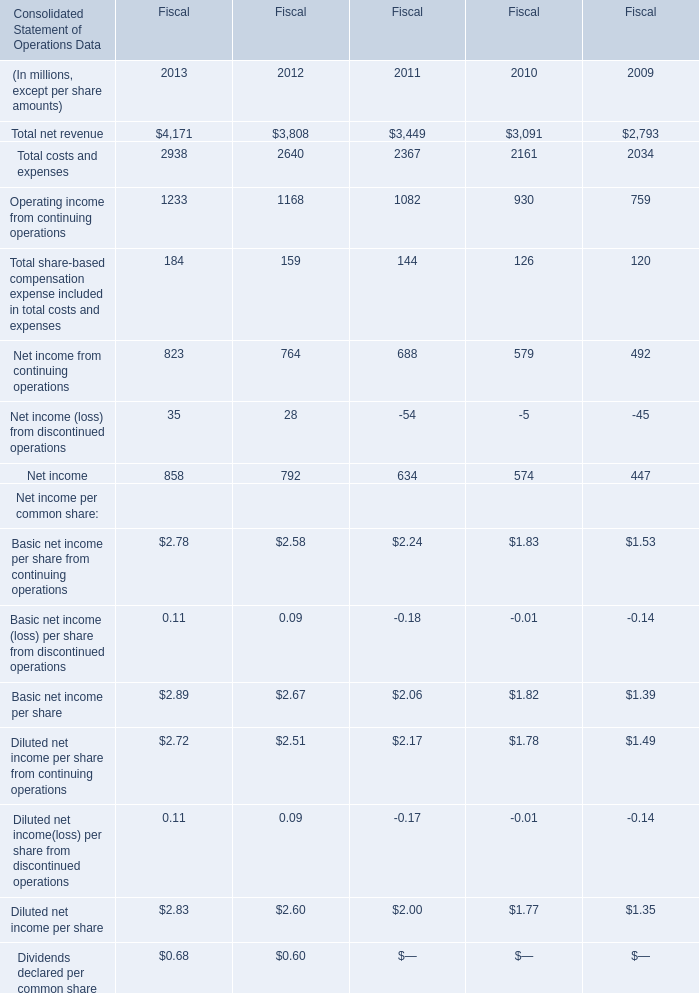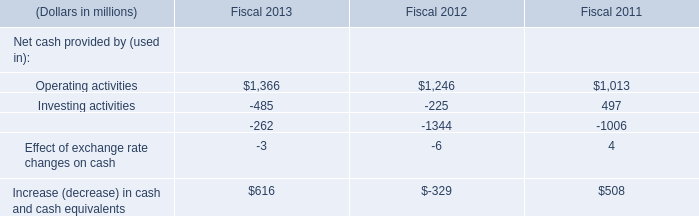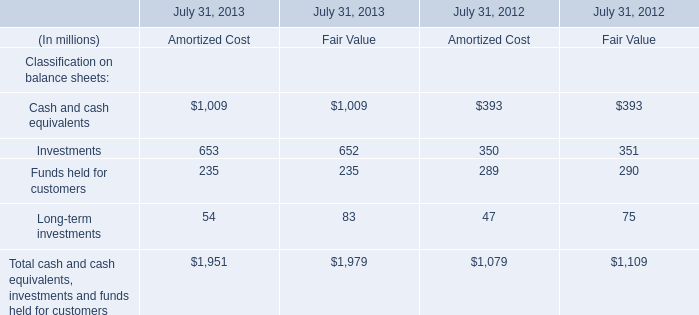what's the total amount of Operating activities of Fiscal 2011, and Cash and cash equivalents of July 31, 2013 Amortized Cost ? 
Computations: (1013.0 + 1009.0)
Answer: 2022.0. What will Operating income from continuing operations be like in 2014 if it develops with the same increasing rate as current in terms of Fiscal? (in million) 
Computations: (1233 * (1 + ((1233 - 1168) / 1168)))
Answer: 1301.61729. What is the sum of Operating income from continuing operations of Fiscal 2013, and Financing activities of Fiscal 2012 ? 
Computations: (1233.0 + 1344.0)
Answer: 2577.0. 